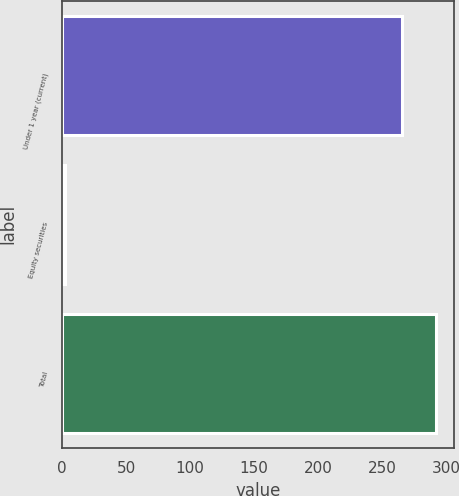Convert chart. <chart><loc_0><loc_0><loc_500><loc_500><bar_chart><fcel>Under 1 year (current)<fcel>Equity securities<fcel>Total<nl><fcel>265.4<fcel>1.8<fcel>291.94<nl></chart> 